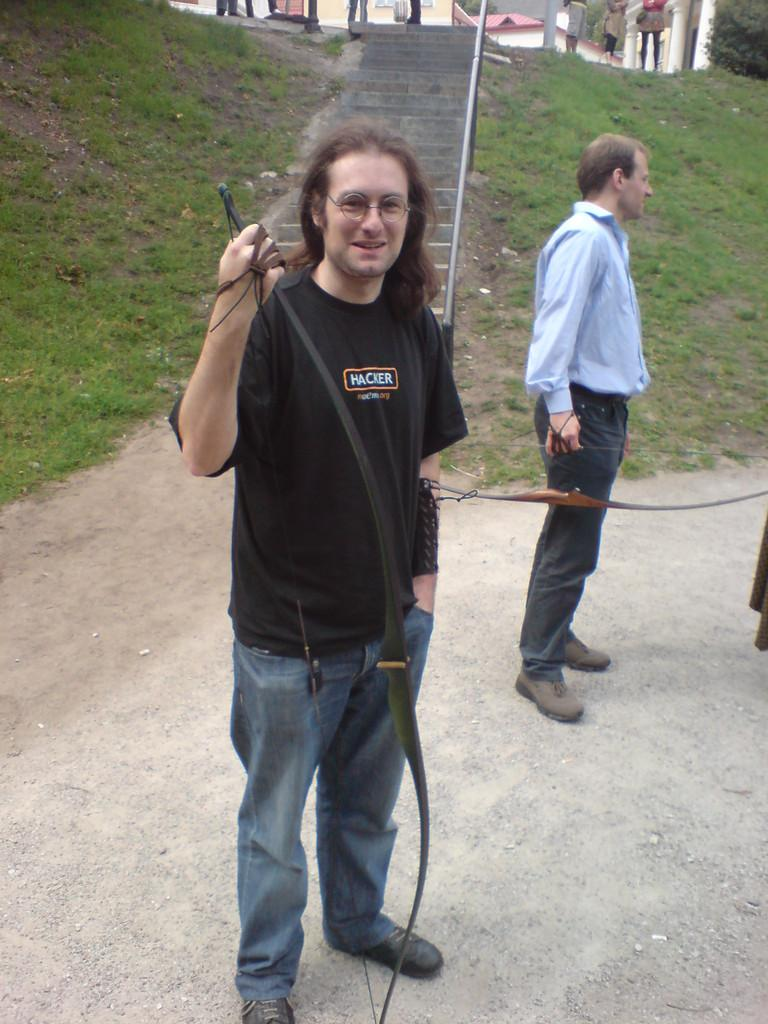What is the man in the foreground doing in the image? The man is holding an object in the foreground. Can you describe the person behind the man? There is another person behind the man. What architectural feature can be seen in the background? There are stairs in the background. What type of natural environment is visible in the background? There is grassland in the background. What type of structures are visible in the background? There are houses in the background. Are there any other people visible in the image? Yes, there are people in the background. What type of cast can be seen on the tiger in the image? There is no tiger present in the image, and therefore no cast can be observed. Where is the mailbox located in the image? There is no mailbox present in the image. 